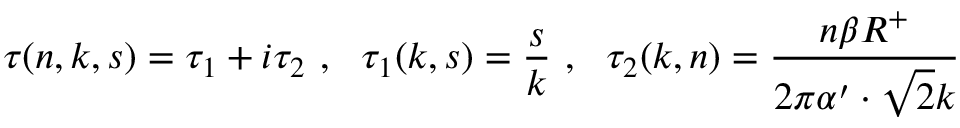<formula> <loc_0><loc_0><loc_500><loc_500>\tau ( n , k , s ) = \tau _ { 1 } + i \tau _ { 2 } , \tau _ { 1 } ( k , s ) = \frac { s } { k } , \tau _ { 2 } ( k , n ) = \frac { n \beta R ^ { + } } { 2 \pi \alpha ^ { \prime } \cdot \sqrt { 2 } k }</formula> 